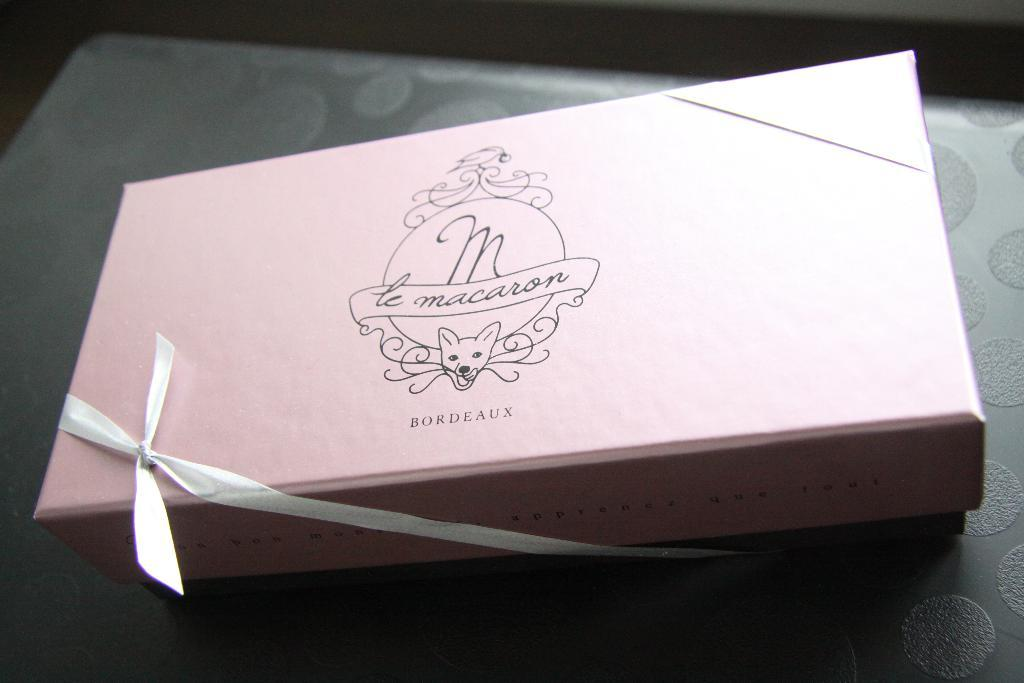<image>
Present a compact description of the photo's key features. A pink box of macaroons from Bordeaux with a white ribbon. 